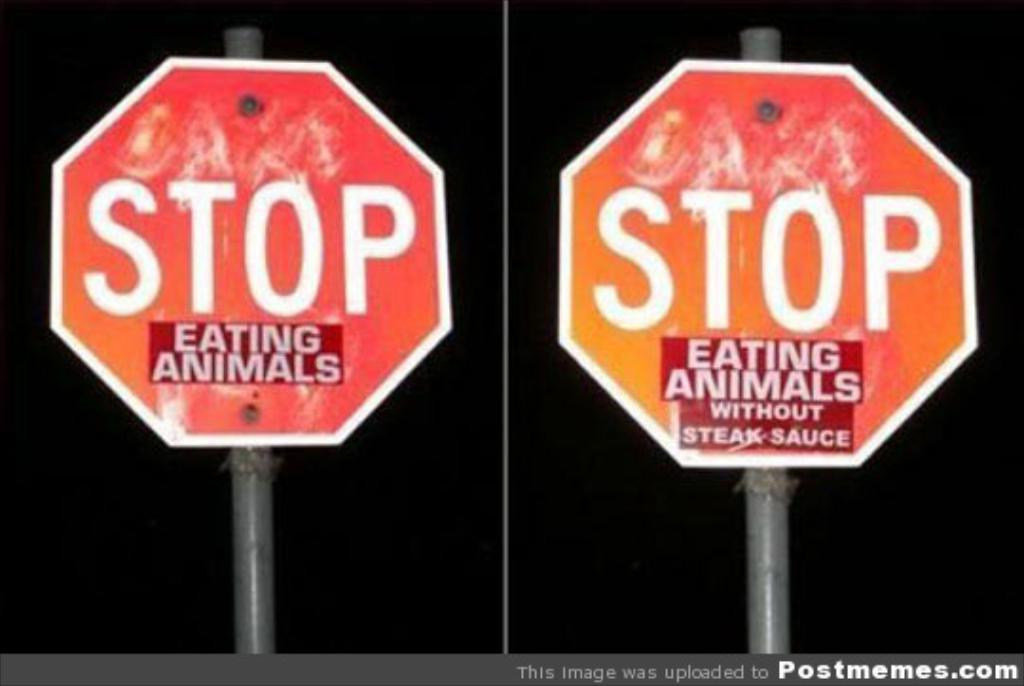<image>
Present a compact description of the photo's key features. Two STOP signs that have added stickers about eating animals under them. 